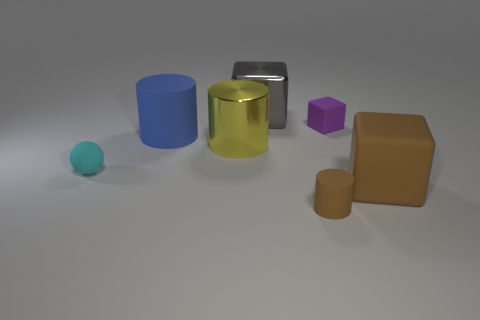Add 1 spheres. How many objects exist? 8 Subtract all cubes. How many objects are left? 4 Subtract 1 brown cubes. How many objects are left? 6 Subtract all cyan things. Subtract all tiny cyan spheres. How many objects are left? 5 Add 4 brown rubber objects. How many brown rubber objects are left? 6 Add 4 brown metal cylinders. How many brown metal cylinders exist? 4 